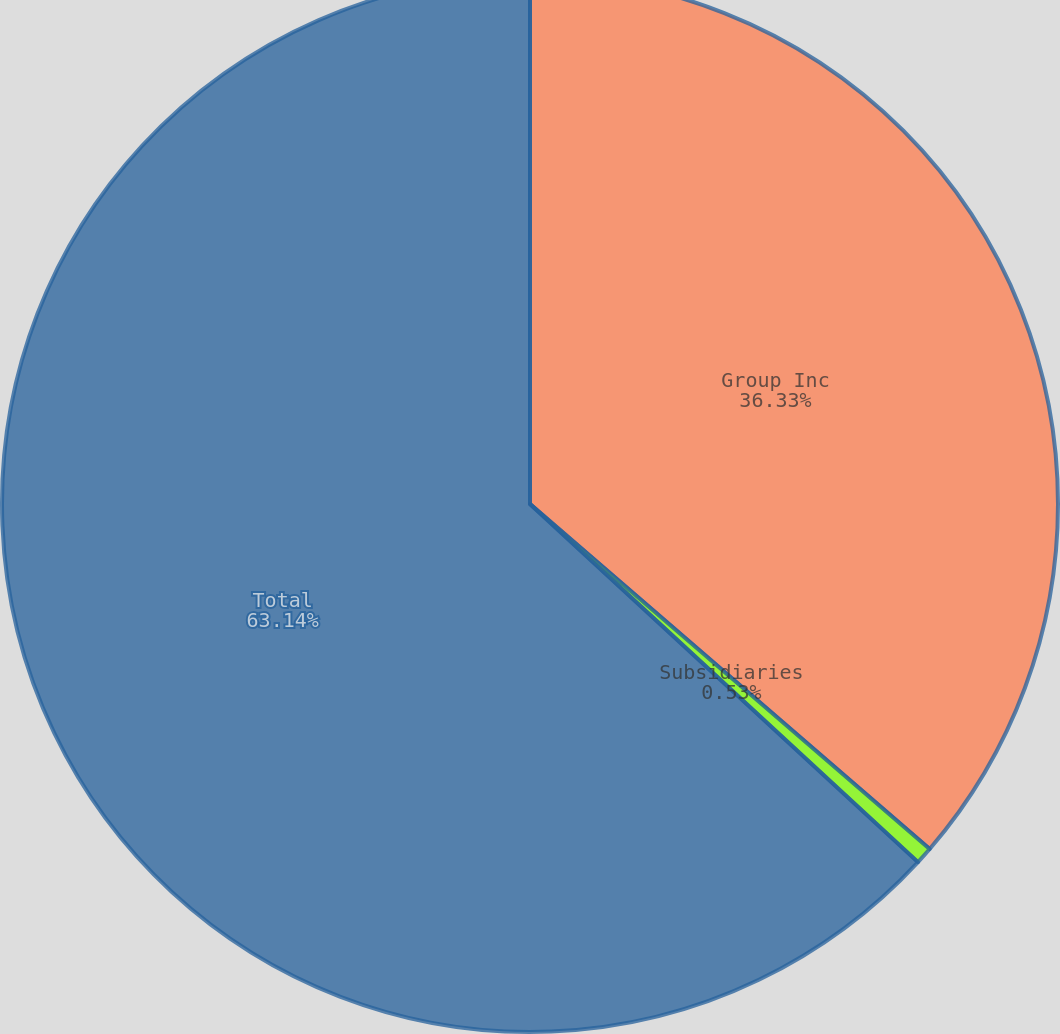Convert chart. <chart><loc_0><loc_0><loc_500><loc_500><pie_chart><fcel>Group Inc<fcel>Subsidiaries<fcel>Total<nl><fcel>36.33%<fcel>0.53%<fcel>63.13%<nl></chart> 